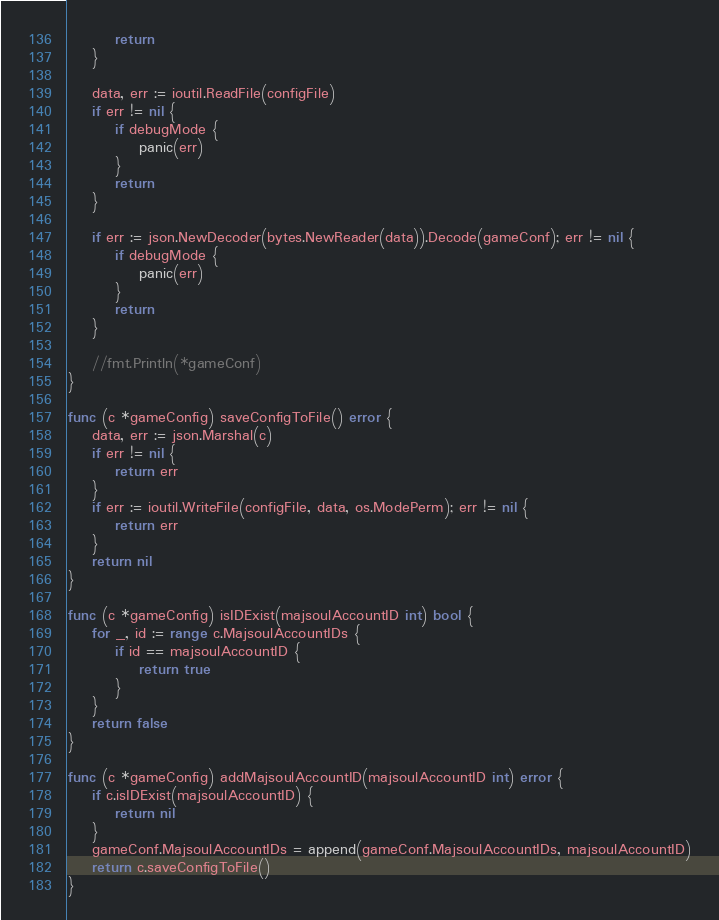<code> <loc_0><loc_0><loc_500><loc_500><_Go_>		return
	}

	data, err := ioutil.ReadFile(configFile)
	if err != nil {
		if debugMode {
			panic(err)
		}
		return
	}

	if err := json.NewDecoder(bytes.NewReader(data)).Decode(gameConf); err != nil {
		if debugMode {
			panic(err)
		}
		return
	}

	//fmt.Println(*gameConf)
}

func (c *gameConfig) saveConfigToFile() error {
	data, err := json.Marshal(c)
	if err != nil {
		return err
	}
	if err := ioutil.WriteFile(configFile, data, os.ModePerm); err != nil {
		return err
	}
	return nil
}

func (c *gameConfig) isIDExist(majsoulAccountID int) bool {
	for _, id := range c.MajsoulAccountIDs {
		if id == majsoulAccountID {
			return true
		}
	}
	return false
}

func (c *gameConfig) addMajsoulAccountID(majsoulAccountID int) error {
	if c.isIDExist(majsoulAccountID) {
		return nil
	}
	gameConf.MajsoulAccountIDs = append(gameConf.MajsoulAccountIDs, majsoulAccountID)
	return c.saveConfigToFile()
}
</code> 